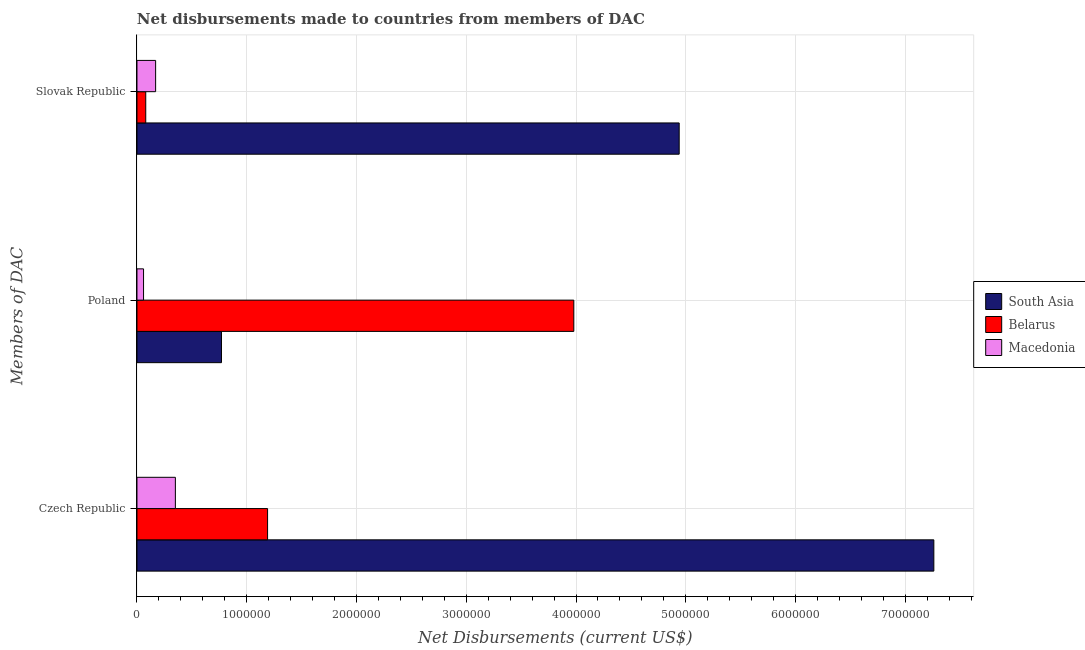How many groups of bars are there?
Make the answer very short. 3. What is the label of the 1st group of bars from the top?
Give a very brief answer. Slovak Republic. What is the net disbursements made by czech republic in Macedonia?
Offer a terse response. 3.50e+05. Across all countries, what is the maximum net disbursements made by slovak republic?
Ensure brevity in your answer.  4.94e+06. Across all countries, what is the minimum net disbursements made by poland?
Your answer should be very brief. 6.00e+04. In which country was the net disbursements made by poland maximum?
Your response must be concise. Belarus. In which country was the net disbursements made by czech republic minimum?
Your response must be concise. Macedonia. What is the total net disbursements made by slovak republic in the graph?
Your answer should be compact. 5.19e+06. What is the difference between the net disbursements made by czech republic in Macedonia and that in South Asia?
Offer a very short reply. -6.91e+06. What is the difference between the net disbursements made by poland in South Asia and the net disbursements made by slovak republic in Macedonia?
Provide a succinct answer. 6.00e+05. What is the average net disbursements made by poland per country?
Provide a succinct answer. 1.60e+06. What is the difference between the net disbursements made by slovak republic and net disbursements made by czech republic in Belarus?
Your response must be concise. -1.11e+06. In how many countries, is the net disbursements made by poland greater than 3400000 US$?
Offer a very short reply. 1. What is the ratio of the net disbursements made by slovak republic in South Asia to that in Macedonia?
Offer a very short reply. 29.06. Is the net disbursements made by slovak republic in South Asia less than that in Macedonia?
Provide a succinct answer. No. Is the difference between the net disbursements made by czech republic in South Asia and Belarus greater than the difference between the net disbursements made by poland in South Asia and Belarus?
Offer a very short reply. Yes. What is the difference between the highest and the second highest net disbursements made by czech republic?
Your answer should be very brief. 6.07e+06. What is the difference between the highest and the lowest net disbursements made by czech republic?
Give a very brief answer. 6.91e+06. In how many countries, is the net disbursements made by slovak republic greater than the average net disbursements made by slovak republic taken over all countries?
Offer a very short reply. 1. What does the 1st bar from the top in Slovak Republic represents?
Keep it short and to the point. Macedonia. What does the 2nd bar from the bottom in Poland represents?
Make the answer very short. Belarus. How many bars are there?
Your answer should be compact. 9. Are all the bars in the graph horizontal?
Ensure brevity in your answer.  Yes. How many countries are there in the graph?
Your answer should be very brief. 3. What is the difference between two consecutive major ticks on the X-axis?
Ensure brevity in your answer.  1.00e+06. Are the values on the major ticks of X-axis written in scientific E-notation?
Keep it short and to the point. No. Does the graph contain any zero values?
Offer a very short reply. No. Where does the legend appear in the graph?
Your answer should be compact. Center right. How many legend labels are there?
Your response must be concise. 3. How are the legend labels stacked?
Provide a succinct answer. Vertical. What is the title of the graph?
Make the answer very short. Net disbursements made to countries from members of DAC. What is the label or title of the X-axis?
Your answer should be very brief. Net Disbursements (current US$). What is the label or title of the Y-axis?
Your answer should be compact. Members of DAC. What is the Net Disbursements (current US$) of South Asia in Czech Republic?
Provide a short and direct response. 7.26e+06. What is the Net Disbursements (current US$) in Belarus in Czech Republic?
Provide a short and direct response. 1.19e+06. What is the Net Disbursements (current US$) of Macedonia in Czech Republic?
Your response must be concise. 3.50e+05. What is the Net Disbursements (current US$) of South Asia in Poland?
Give a very brief answer. 7.70e+05. What is the Net Disbursements (current US$) of Belarus in Poland?
Your answer should be very brief. 3.98e+06. What is the Net Disbursements (current US$) in Macedonia in Poland?
Offer a very short reply. 6.00e+04. What is the Net Disbursements (current US$) in South Asia in Slovak Republic?
Provide a succinct answer. 4.94e+06. Across all Members of DAC, what is the maximum Net Disbursements (current US$) in South Asia?
Give a very brief answer. 7.26e+06. Across all Members of DAC, what is the maximum Net Disbursements (current US$) in Belarus?
Offer a very short reply. 3.98e+06. Across all Members of DAC, what is the maximum Net Disbursements (current US$) in Macedonia?
Your answer should be very brief. 3.50e+05. Across all Members of DAC, what is the minimum Net Disbursements (current US$) of South Asia?
Provide a short and direct response. 7.70e+05. Across all Members of DAC, what is the minimum Net Disbursements (current US$) in Macedonia?
Provide a succinct answer. 6.00e+04. What is the total Net Disbursements (current US$) of South Asia in the graph?
Your answer should be compact. 1.30e+07. What is the total Net Disbursements (current US$) in Belarus in the graph?
Ensure brevity in your answer.  5.25e+06. What is the total Net Disbursements (current US$) in Macedonia in the graph?
Provide a short and direct response. 5.80e+05. What is the difference between the Net Disbursements (current US$) in South Asia in Czech Republic and that in Poland?
Provide a succinct answer. 6.49e+06. What is the difference between the Net Disbursements (current US$) in Belarus in Czech Republic and that in Poland?
Offer a very short reply. -2.79e+06. What is the difference between the Net Disbursements (current US$) of South Asia in Czech Republic and that in Slovak Republic?
Your response must be concise. 2.32e+06. What is the difference between the Net Disbursements (current US$) in Belarus in Czech Republic and that in Slovak Republic?
Your answer should be compact. 1.11e+06. What is the difference between the Net Disbursements (current US$) in Macedonia in Czech Republic and that in Slovak Republic?
Provide a short and direct response. 1.80e+05. What is the difference between the Net Disbursements (current US$) of South Asia in Poland and that in Slovak Republic?
Your response must be concise. -4.17e+06. What is the difference between the Net Disbursements (current US$) in Belarus in Poland and that in Slovak Republic?
Provide a short and direct response. 3.90e+06. What is the difference between the Net Disbursements (current US$) in South Asia in Czech Republic and the Net Disbursements (current US$) in Belarus in Poland?
Provide a succinct answer. 3.28e+06. What is the difference between the Net Disbursements (current US$) in South Asia in Czech Republic and the Net Disbursements (current US$) in Macedonia in Poland?
Provide a short and direct response. 7.20e+06. What is the difference between the Net Disbursements (current US$) of Belarus in Czech Republic and the Net Disbursements (current US$) of Macedonia in Poland?
Give a very brief answer. 1.13e+06. What is the difference between the Net Disbursements (current US$) in South Asia in Czech Republic and the Net Disbursements (current US$) in Belarus in Slovak Republic?
Make the answer very short. 7.18e+06. What is the difference between the Net Disbursements (current US$) of South Asia in Czech Republic and the Net Disbursements (current US$) of Macedonia in Slovak Republic?
Your answer should be compact. 7.09e+06. What is the difference between the Net Disbursements (current US$) in Belarus in Czech Republic and the Net Disbursements (current US$) in Macedonia in Slovak Republic?
Provide a succinct answer. 1.02e+06. What is the difference between the Net Disbursements (current US$) of South Asia in Poland and the Net Disbursements (current US$) of Belarus in Slovak Republic?
Give a very brief answer. 6.90e+05. What is the difference between the Net Disbursements (current US$) in Belarus in Poland and the Net Disbursements (current US$) in Macedonia in Slovak Republic?
Provide a succinct answer. 3.81e+06. What is the average Net Disbursements (current US$) in South Asia per Members of DAC?
Ensure brevity in your answer.  4.32e+06. What is the average Net Disbursements (current US$) in Belarus per Members of DAC?
Make the answer very short. 1.75e+06. What is the average Net Disbursements (current US$) in Macedonia per Members of DAC?
Provide a short and direct response. 1.93e+05. What is the difference between the Net Disbursements (current US$) of South Asia and Net Disbursements (current US$) of Belarus in Czech Republic?
Ensure brevity in your answer.  6.07e+06. What is the difference between the Net Disbursements (current US$) of South Asia and Net Disbursements (current US$) of Macedonia in Czech Republic?
Offer a terse response. 6.91e+06. What is the difference between the Net Disbursements (current US$) in Belarus and Net Disbursements (current US$) in Macedonia in Czech Republic?
Make the answer very short. 8.40e+05. What is the difference between the Net Disbursements (current US$) of South Asia and Net Disbursements (current US$) of Belarus in Poland?
Offer a terse response. -3.21e+06. What is the difference between the Net Disbursements (current US$) of South Asia and Net Disbursements (current US$) of Macedonia in Poland?
Make the answer very short. 7.10e+05. What is the difference between the Net Disbursements (current US$) in Belarus and Net Disbursements (current US$) in Macedonia in Poland?
Your response must be concise. 3.92e+06. What is the difference between the Net Disbursements (current US$) in South Asia and Net Disbursements (current US$) in Belarus in Slovak Republic?
Offer a very short reply. 4.86e+06. What is the difference between the Net Disbursements (current US$) of South Asia and Net Disbursements (current US$) of Macedonia in Slovak Republic?
Give a very brief answer. 4.77e+06. What is the difference between the Net Disbursements (current US$) of Belarus and Net Disbursements (current US$) of Macedonia in Slovak Republic?
Give a very brief answer. -9.00e+04. What is the ratio of the Net Disbursements (current US$) in South Asia in Czech Republic to that in Poland?
Keep it short and to the point. 9.43. What is the ratio of the Net Disbursements (current US$) in Belarus in Czech Republic to that in Poland?
Your answer should be very brief. 0.3. What is the ratio of the Net Disbursements (current US$) in Macedonia in Czech Republic to that in Poland?
Your answer should be very brief. 5.83. What is the ratio of the Net Disbursements (current US$) in South Asia in Czech Republic to that in Slovak Republic?
Provide a short and direct response. 1.47. What is the ratio of the Net Disbursements (current US$) of Belarus in Czech Republic to that in Slovak Republic?
Provide a short and direct response. 14.88. What is the ratio of the Net Disbursements (current US$) in Macedonia in Czech Republic to that in Slovak Republic?
Give a very brief answer. 2.06. What is the ratio of the Net Disbursements (current US$) of South Asia in Poland to that in Slovak Republic?
Offer a very short reply. 0.16. What is the ratio of the Net Disbursements (current US$) in Belarus in Poland to that in Slovak Republic?
Ensure brevity in your answer.  49.75. What is the ratio of the Net Disbursements (current US$) in Macedonia in Poland to that in Slovak Republic?
Your answer should be very brief. 0.35. What is the difference between the highest and the second highest Net Disbursements (current US$) of South Asia?
Provide a short and direct response. 2.32e+06. What is the difference between the highest and the second highest Net Disbursements (current US$) of Belarus?
Offer a very short reply. 2.79e+06. What is the difference between the highest and the lowest Net Disbursements (current US$) in South Asia?
Offer a very short reply. 6.49e+06. What is the difference between the highest and the lowest Net Disbursements (current US$) of Belarus?
Keep it short and to the point. 3.90e+06. 